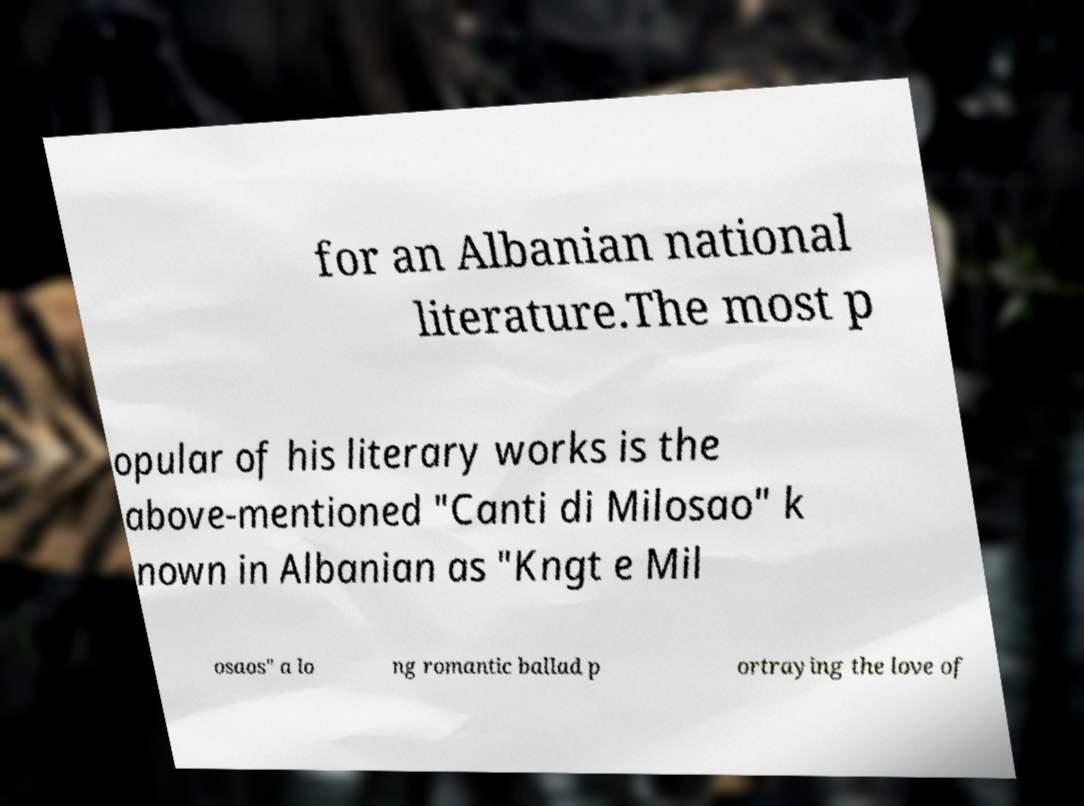There's text embedded in this image that I need extracted. Can you transcribe it verbatim? for an Albanian national literature.The most p opular of his literary works is the above-mentioned "Canti di Milosao" k nown in Albanian as "Kngt e Mil osaos" a lo ng romantic ballad p ortraying the love of 